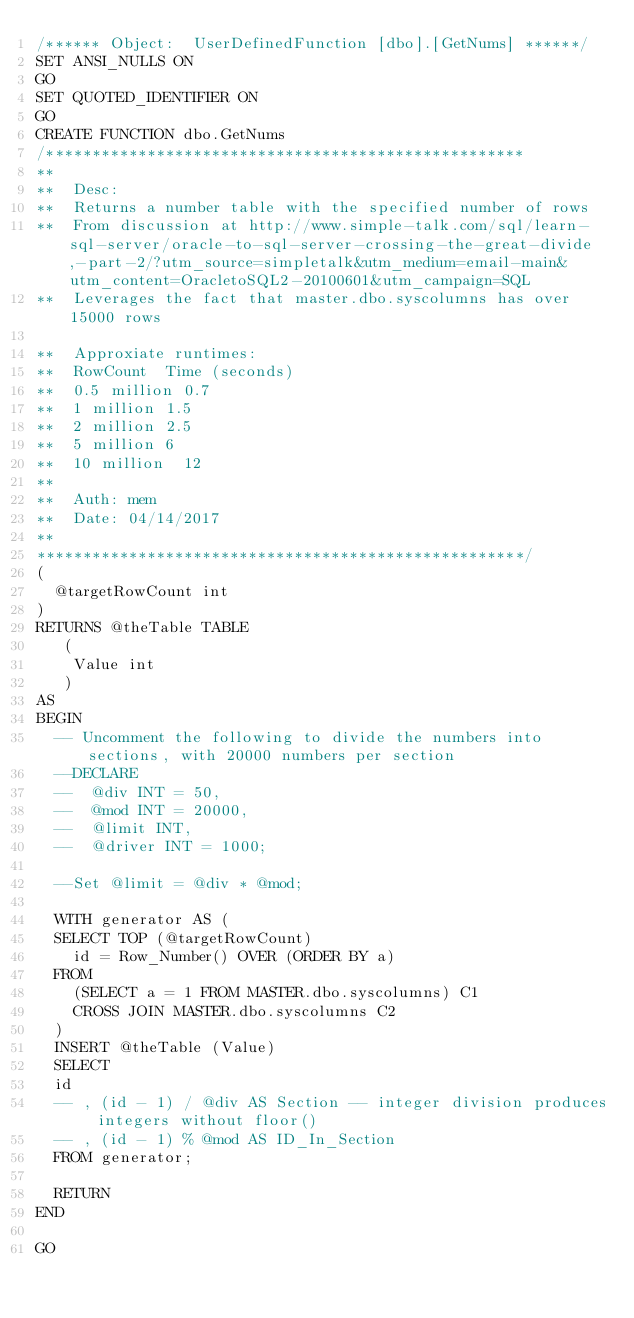<code> <loc_0><loc_0><loc_500><loc_500><_SQL_>/****** Object:  UserDefinedFunction [dbo].[GetNums] ******/
SET ANSI_NULLS ON
GO
SET QUOTED_IDENTIFIER ON
GO
CREATE FUNCTION dbo.GetNums
/****************************************************
**
**	Desc: 
**  Returns a number table with the specified number of rows
**  From discussion at http://www.simple-talk.com/sql/learn-sql-server/oracle-to-sql-server-crossing-the-great-divide,-part-2/?utm_source=simpletalk&utm_medium=email-main&utm_content=OracletoSQL2-20100601&utm_campaign=SQL
**	Leverages the fact that master.dbo.syscolumns has over 15000 rows

**  Approxiate runtimes:
**	RowCount	Time (seconds)
**  0.5 million	0.7
**	1 million	1.5
**	2 million	2.5
**	5 million	6
**	10 million	12
**
**	Auth:	mem
**	Date:	04/14/2017
**    
*****************************************************/
(
	@targetRowCount int
)
RETURNS @theTable TABLE
   (
    Value int
   )
AS
BEGIN
	-- Uncomment the following to divide the numbers into sections, with 20000 numbers per section
	--DECLARE
	--  @div INT = 50,
	--  @mod INT = 20000,
	--  @limit INT,
	--  @driver INT = 1000;
   
	--Set @limit = @div * @mod;
   
	WITH generator AS (
	SELECT TOP (@targetRowCount)
		id = Row_Number() OVER (ORDER BY a)
	FROM
		(SELECT a = 1 FROM MASTER.dbo.syscolumns) C1
		CROSS JOIN MASTER.dbo.syscolumns C2
	)
	INSERT @theTable (Value)
	SELECT
	id
	-- , (id - 1) / @div AS Section -- integer division produces integers without floor()
	-- , (id - 1) % @mod AS ID_In_Section
	FROM generator;
	
	RETURN
END

GO
</code> 